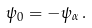<formula> <loc_0><loc_0><loc_500><loc_500>\psi _ { 0 } = - \psi _ { \alpha } \, .</formula> 